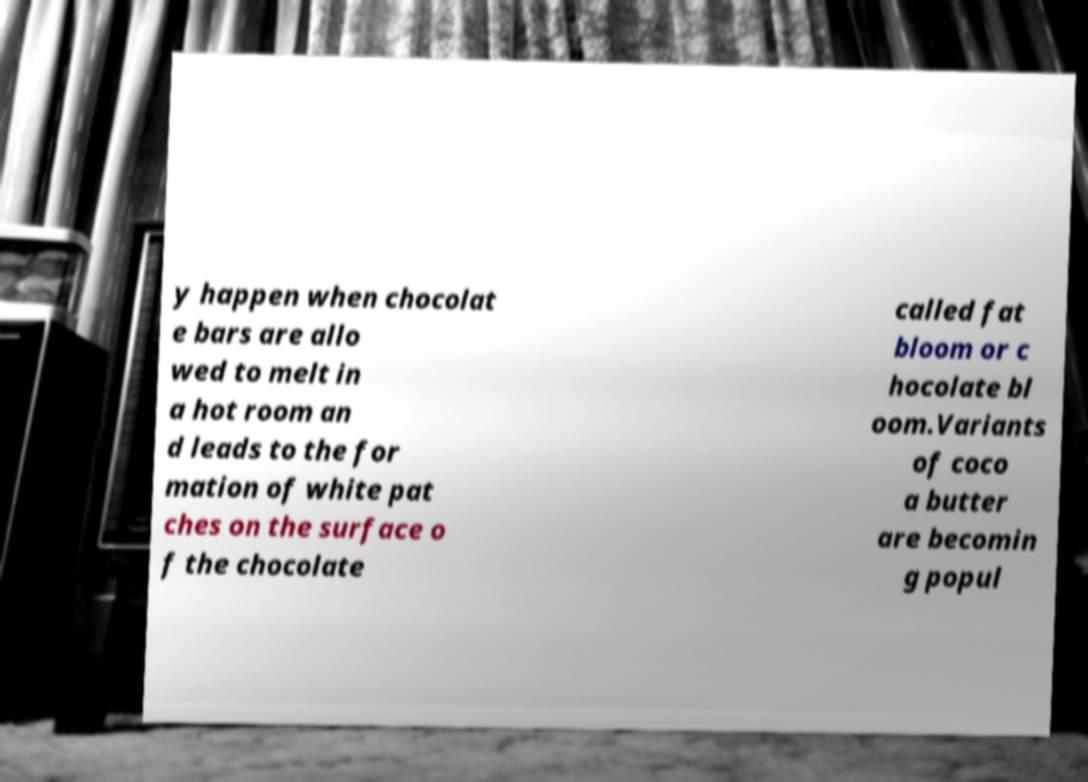Could you extract and type out the text from this image? y happen when chocolat e bars are allo wed to melt in a hot room an d leads to the for mation of white pat ches on the surface o f the chocolate called fat bloom or c hocolate bl oom.Variants of coco a butter are becomin g popul 